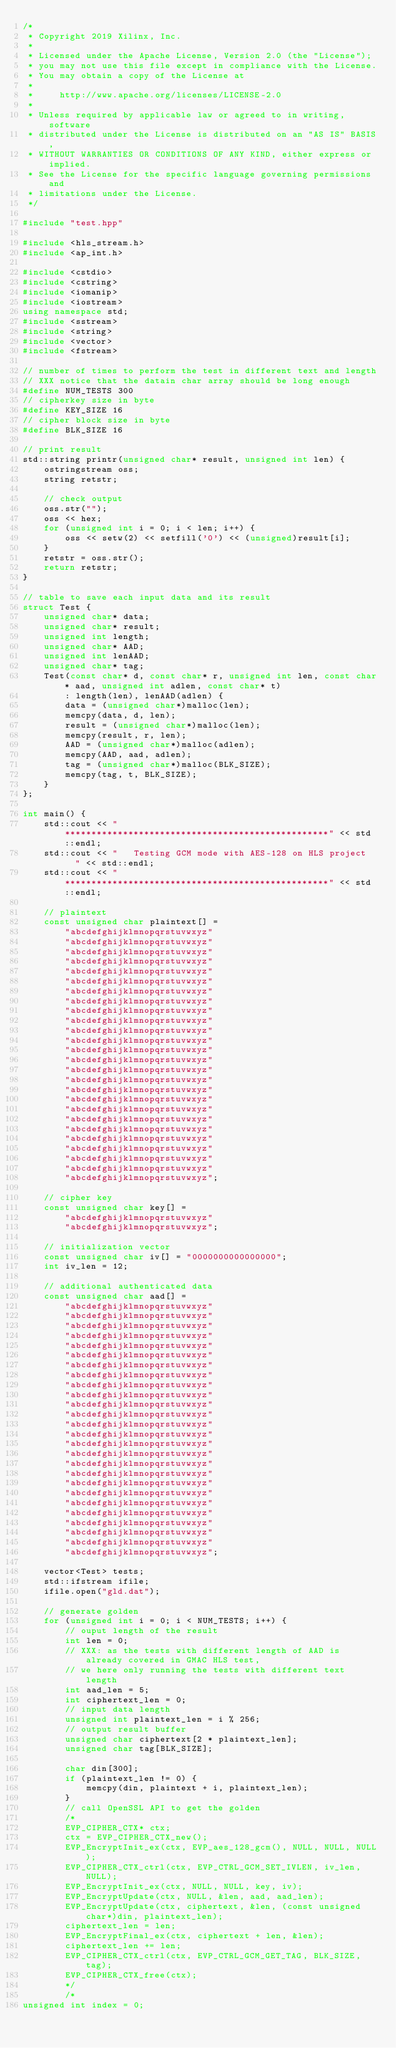Convert code to text. <code><loc_0><loc_0><loc_500><loc_500><_C++_>/*
 * Copyright 2019 Xilinx, Inc.
 *
 * Licensed under the Apache License, Version 2.0 (the "License");
 * you may not use this file except in compliance with the License.
 * You may obtain a copy of the License at
 *
 *     http://www.apache.org/licenses/LICENSE-2.0
 *
 * Unless required by applicable law or agreed to in writing, software
 * distributed under the License is distributed on an "AS IS" BASIS,
 * WITHOUT WARRANTIES OR CONDITIONS OF ANY KIND, either express or implied.
 * See the License for the specific language governing permissions and
 * limitations under the License.
 */

#include "test.hpp"

#include <hls_stream.h>
#include <ap_int.h>

#include <cstdio>
#include <cstring>
#include <iomanip>
#include <iostream>
using namespace std;
#include <sstream>
#include <string>
#include <vector>
#include <fstream>

// number of times to perform the test in different text and length
// XXX notice that the datain char array should be long enough
#define NUM_TESTS 300
// cipherkey size in byte
#define KEY_SIZE 16
// cipher block size in byte
#define BLK_SIZE 16

// print result
std::string printr(unsigned char* result, unsigned int len) {
    ostringstream oss;
    string retstr;

    // check output
    oss.str("");
    oss << hex;
    for (unsigned int i = 0; i < len; i++) {
        oss << setw(2) << setfill('0') << (unsigned)result[i];
    }
    retstr = oss.str();
    return retstr;
}

// table to save each input data and its result
struct Test {
    unsigned char* data;
    unsigned char* result;
    unsigned int length;
    unsigned char* AAD;
    unsigned int lenAAD;
    unsigned char* tag;
    Test(const char* d, const char* r, unsigned int len, const char* aad, unsigned int adlen, const char* t)
        : length(len), lenAAD(adlen) {
        data = (unsigned char*)malloc(len);
        memcpy(data, d, len);
        result = (unsigned char*)malloc(len);
        memcpy(result, r, len);
        AAD = (unsigned char*)malloc(adlen);
        memcpy(AAD, aad, adlen);
        tag = (unsigned char*)malloc(BLK_SIZE);
        memcpy(tag, t, BLK_SIZE);
    }
};

int main() {
    std::cout << "**************************************************" << std::endl;
    std::cout << "   Testing GCM mode with AES-128 on HLS project   " << std::endl;
    std::cout << "**************************************************" << std::endl;

    // plaintext
    const unsigned char plaintext[] =
        "abcdefghijklmnopqrstuvwxyz"
        "abcdefghijklmnopqrstuvwxyz"
        "abcdefghijklmnopqrstuvwxyz"
        "abcdefghijklmnopqrstuvwxyz"
        "abcdefghijklmnopqrstuvwxyz"
        "abcdefghijklmnopqrstuvwxyz"
        "abcdefghijklmnopqrstuvwxyz"
        "abcdefghijklmnopqrstuvwxyz"
        "abcdefghijklmnopqrstuvwxyz"
        "abcdefghijklmnopqrstuvwxyz"
        "abcdefghijklmnopqrstuvwxyz"
        "abcdefghijklmnopqrstuvwxyz"
        "abcdefghijklmnopqrstuvwxyz"
        "abcdefghijklmnopqrstuvwxyz"
        "abcdefghijklmnopqrstuvwxyz"
        "abcdefghijklmnopqrstuvwxyz"
        "abcdefghijklmnopqrstuvwxyz"
        "abcdefghijklmnopqrstuvwxyz"
        "abcdefghijklmnopqrstuvwxyz"
        "abcdefghijklmnopqrstuvwxyz"
        "abcdefghijklmnopqrstuvwxyz"
        "abcdefghijklmnopqrstuvwxyz"
        "abcdefghijklmnopqrstuvwxyz"
        "abcdefghijklmnopqrstuvwxyz"
        "abcdefghijklmnopqrstuvwxyz"
        "abcdefghijklmnopqrstuvwxyz";

    // cipher key
    const unsigned char key[] =
        "abcdefghijklmnopqrstuvwxyz"
        "abcdefghijklmnopqrstuvwxyz";

    // initialization vector
    const unsigned char iv[] = "0000000000000000";
    int iv_len = 12;

    // additional authenticated data
    const unsigned char aad[] =
        "abcdefghijklmnopqrstuvwxyz"
        "abcdefghijklmnopqrstuvwxyz"
        "abcdefghijklmnopqrstuvwxyz"
        "abcdefghijklmnopqrstuvwxyz"
        "abcdefghijklmnopqrstuvwxyz"
        "abcdefghijklmnopqrstuvwxyz"
        "abcdefghijklmnopqrstuvwxyz"
        "abcdefghijklmnopqrstuvwxyz"
        "abcdefghijklmnopqrstuvwxyz"
        "abcdefghijklmnopqrstuvwxyz"
        "abcdefghijklmnopqrstuvwxyz"
        "abcdefghijklmnopqrstuvwxyz"
        "abcdefghijklmnopqrstuvwxyz"
        "abcdefghijklmnopqrstuvwxyz"
        "abcdefghijklmnopqrstuvwxyz"
        "abcdefghijklmnopqrstuvwxyz"
        "abcdefghijklmnopqrstuvwxyz"
        "abcdefghijklmnopqrstuvwxyz"
        "abcdefghijklmnopqrstuvwxyz"
        "abcdefghijklmnopqrstuvwxyz"
        "abcdefghijklmnopqrstuvwxyz"
        "abcdefghijklmnopqrstuvwxyz"
        "abcdefghijklmnopqrstuvwxyz"
        "abcdefghijklmnopqrstuvwxyz"
        "abcdefghijklmnopqrstuvwxyz"
        "abcdefghijklmnopqrstuvwxyz";

    vector<Test> tests;
    std::ifstream ifile;
    ifile.open("gld.dat");

    // generate golden
    for (unsigned int i = 0; i < NUM_TESTS; i++) {
        // ouput length of the result
        int len = 0;
        // XXX: as the tests with different length of AAD is already covered in GMAC HLS test,
        // we here only running the tests with different text length
        int aad_len = 5;
        int ciphertext_len = 0;
        // input data length
        unsigned int plaintext_len = i % 256;
        // output result buffer
        unsigned char ciphertext[2 * plaintext_len];
        unsigned char tag[BLK_SIZE];

        char din[300];
        if (plaintext_len != 0) {
            memcpy(din, plaintext + i, plaintext_len);
        }
        // call OpenSSL API to get the golden
        /*
        EVP_CIPHER_CTX* ctx;
        ctx = EVP_CIPHER_CTX_new();
        EVP_EncryptInit_ex(ctx, EVP_aes_128_gcm(), NULL, NULL, NULL);
        EVP_CIPHER_CTX_ctrl(ctx, EVP_CTRL_GCM_SET_IVLEN, iv_len, NULL);
        EVP_EncryptInit_ex(ctx, NULL, NULL, key, iv);
        EVP_EncryptUpdate(ctx, NULL, &len, aad, aad_len);
        EVP_EncryptUpdate(ctx, ciphertext, &len, (const unsigned char*)din, plaintext_len);
        ciphertext_len = len;
        EVP_EncryptFinal_ex(ctx, ciphertext + len, &len);
        ciphertext_len += len;
        EVP_CIPHER_CTX_ctrl(ctx, EVP_CTRL_GCM_GET_TAG, BLK_SIZE, tag);
        EVP_CIPHER_CTX_free(ctx);
        */
        /*
unsigned int index = 0;</code> 